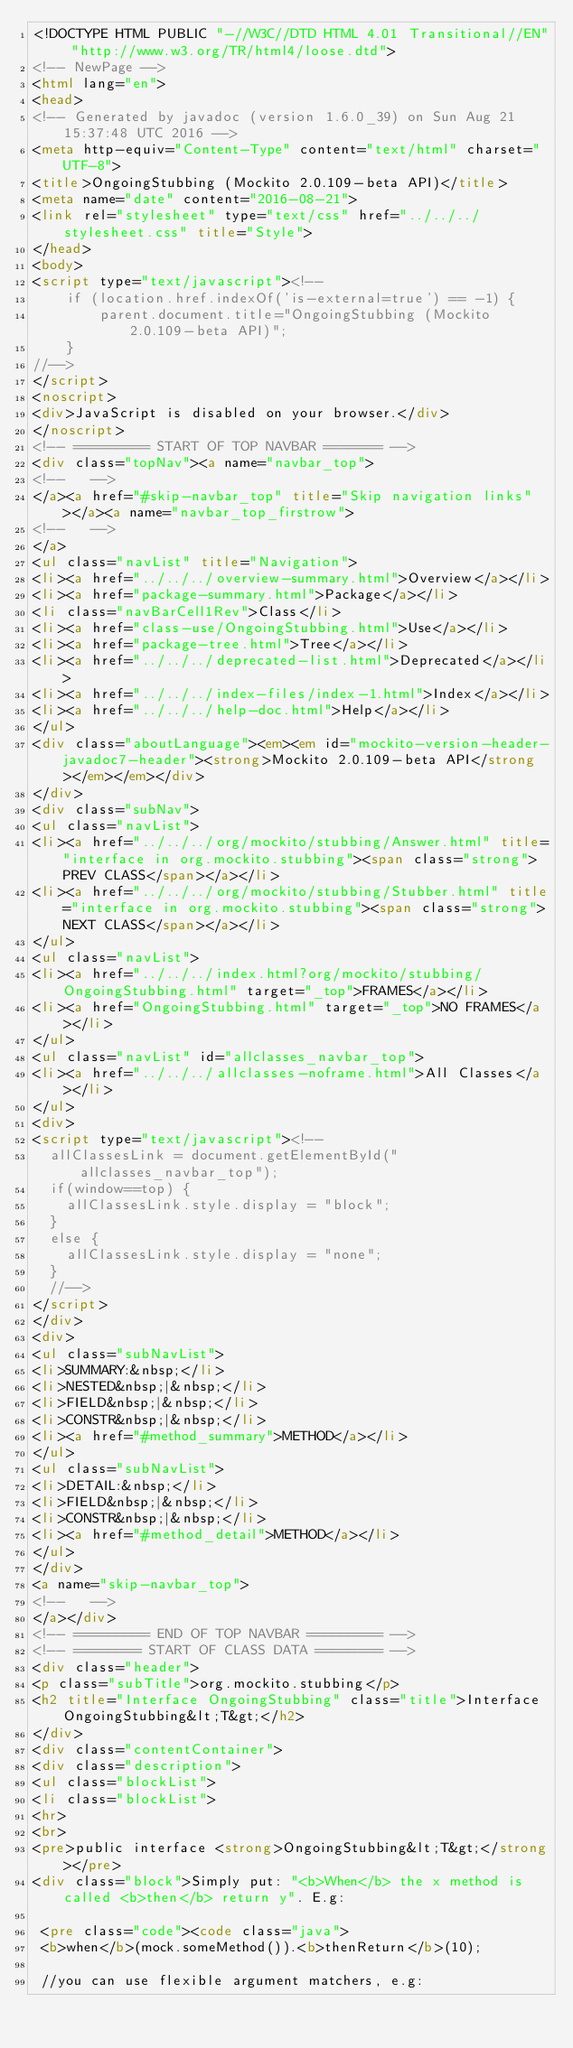Convert code to text. <code><loc_0><loc_0><loc_500><loc_500><_HTML_><!DOCTYPE HTML PUBLIC "-//W3C//DTD HTML 4.01 Transitional//EN" "http://www.w3.org/TR/html4/loose.dtd">
<!-- NewPage -->
<html lang="en">
<head>
<!-- Generated by javadoc (version 1.6.0_39) on Sun Aug 21 15:37:48 UTC 2016 -->
<meta http-equiv="Content-Type" content="text/html" charset="UTF-8">
<title>OngoingStubbing (Mockito 2.0.109-beta API)</title>
<meta name="date" content="2016-08-21">
<link rel="stylesheet" type="text/css" href="../../../stylesheet.css" title="Style">
</head>
<body>
<script type="text/javascript"><!--
    if (location.href.indexOf('is-external=true') == -1) {
        parent.document.title="OngoingStubbing (Mockito 2.0.109-beta API)";
    }
//-->
</script>
<noscript>
<div>JavaScript is disabled on your browser.</div>
</noscript>
<!-- ========= START OF TOP NAVBAR ======= -->
<div class="topNav"><a name="navbar_top">
<!--   -->
</a><a href="#skip-navbar_top" title="Skip navigation links"></a><a name="navbar_top_firstrow">
<!--   -->
</a>
<ul class="navList" title="Navigation">
<li><a href="../../../overview-summary.html">Overview</a></li>
<li><a href="package-summary.html">Package</a></li>
<li class="navBarCell1Rev">Class</li>
<li><a href="class-use/OngoingStubbing.html">Use</a></li>
<li><a href="package-tree.html">Tree</a></li>
<li><a href="../../../deprecated-list.html">Deprecated</a></li>
<li><a href="../../../index-files/index-1.html">Index</a></li>
<li><a href="../../../help-doc.html">Help</a></li>
</ul>
<div class="aboutLanguage"><em><em id="mockito-version-header-javadoc7-header"><strong>Mockito 2.0.109-beta API</strong></em></em></div>
</div>
<div class="subNav">
<ul class="navList">
<li><a href="../../../org/mockito/stubbing/Answer.html" title="interface in org.mockito.stubbing"><span class="strong">PREV CLASS</span></a></li>
<li><a href="../../../org/mockito/stubbing/Stubber.html" title="interface in org.mockito.stubbing"><span class="strong">NEXT CLASS</span></a></li>
</ul>
<ul class="navList">
<li><a href="../../../index.html?org/mockito/stubbing/OngoingStubbing.html" target="_top">FRAMES</a></li>
<li><a href="OngoingStubbing.html" target="_top">NO FRAMES</a></li>
</ul>
<ul class="navList" id="allclasses_navbar_top">
<li><a href="../../../allclasses-noframe.html">All Classes</a></li>
</ul>
<div>
<script type="text/javascript"><!--
  allClassesLink = document.getElementById("allclasses_navbar_top");
  if(window==top) {
    allClassesLink.style.display = "block";
  }
  else {
    allClassesLink.style.display = "none";
  }
  //-->
</script>
</div>
<div>
<ul class="subNavList">
<li>SUMMARY:&nbsp;</li>
<li>NESTED&nbsp;|&nbsp;</li>
<li>FIELD&nbsp;|&nbsp;</li>
<li>CONSTR&nbsp;|&nbsp;</li>
<li><a href="#method_summary">METHOD</a></li>
</ul>
<ul class="subNavList">
<li>DETAIL:&nbsp;</li>
<li>FIELD&nbsp;|&nbsp;</li>
<li>CONSTR&nbsp;|&nbsp;</li>
<li><a href="#method_detail">METHOD</a></li>
</ul>
</div>
<a name="skip-navbar_top">
<!--   -->
</a></div>
<!-- ========= END OF TOP NAVBAR ========= -->
<!-- ======== START OF CLASS DATA ======== -->
<div class="header">
<p class="subTitle">org.mockito.stubbing</p>
<h2 title="Interface OngoingStubbing" class="title">Interface OngoingStubbing&lt;T&gt;</h2>
</div>
<div class="contentContainer">
<div class="description">
<ul class="blockList">
<li class="blockList">
<hr>
<br>
<pre>public interface <strong>OngoingStubbing&lt;T&gt;</strong></pre>
<div class="block">Simply put: "<b>When</b> the x method is called <b>then</b> return y". E.g:

 <pre class="code"><code class="java">
 <b>when</b>(mock.someMethod()).<b>thenReturn</b>(10);

 //you can use flexible argument matchers, e.g:</code> 